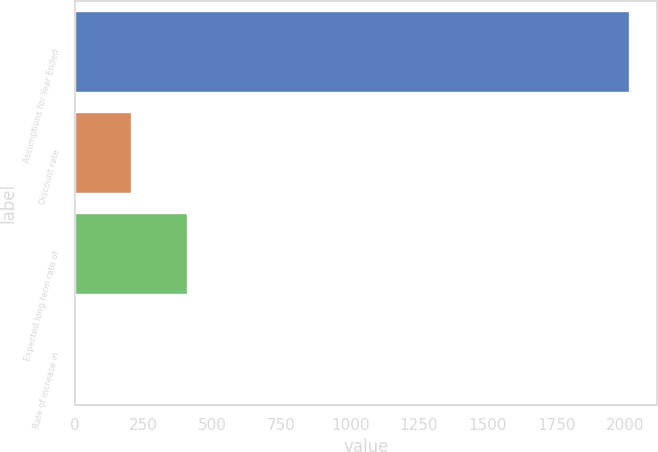Convert chart to OTSL. <chart><loc_0><loc_0><loc_500><loc_500><bar_chart><fcel>Assumptions for Year Ended<fcel>Discount rate<fcel>Expected long-term rate of<fcel>Rate of increase in<nl><fcel>2014<fcel>204.8<fcel>405.82<fcel>3.78<nl></chart> 